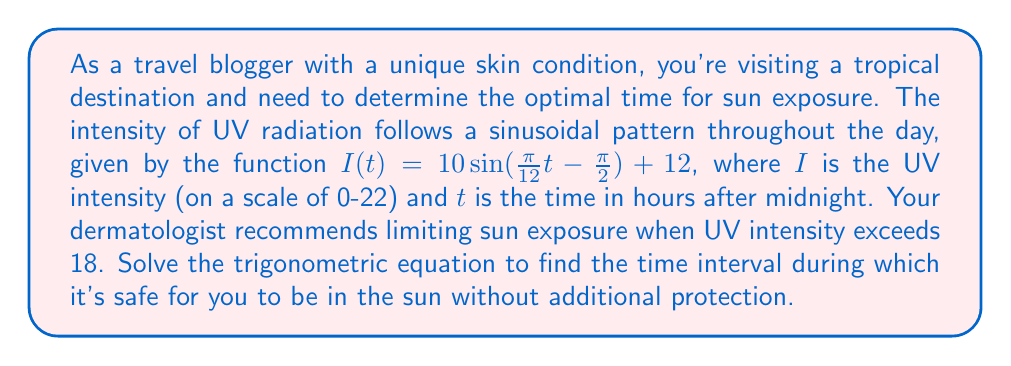Can you solve this math problem? To solve this problem, we need to find the times when the UV intensity is equal to 18. We'll set up the equation and solve for $t$.

1) Set up the equation:
   $18 = 10 \sin(\frac{\pi}{12}t - \frac{\pi}{2}) + 12$

2) Subtract 12 from both sides:
   $6 = 10 \sin(\frac{\pi}{12}t - \frac{\pi}{2})$

3) Divide both sides by 10:
   $0.6 = \sin(\frac{\pi}{12}t - \frac{\pi}{2})$

4) Take the arcsine of both sides:
   $\arcsin(0.6) = \frac{\pi}{12}t - \frac{\pi}{2}$

5) Solve for $t$:
   $\frac{\pi}{12}t = \arcsin(0.6) + \frac{\pi}{2}$
   $t = \frac{12}{\pi}(\arcsin(0.6) + \frac{\pi}{2})$

6) Calculate the first solution:
   $t_1 \approx 7.11$ hours after midnight (about 7:07 AM)

7) To find the second solution, use the property of periodic functions:
   $t_2 = 24 - t_1 \approx 16.89$ hours after midnight (about 4:53 PM)

Therefore, it's safe to be in the sun without additional protection between approximately 7:07 AM and 4:53 PM.
Answer: The safe time interval for sun exposure without additional protection is approximately 7:07 AM to 4:53 PM. 